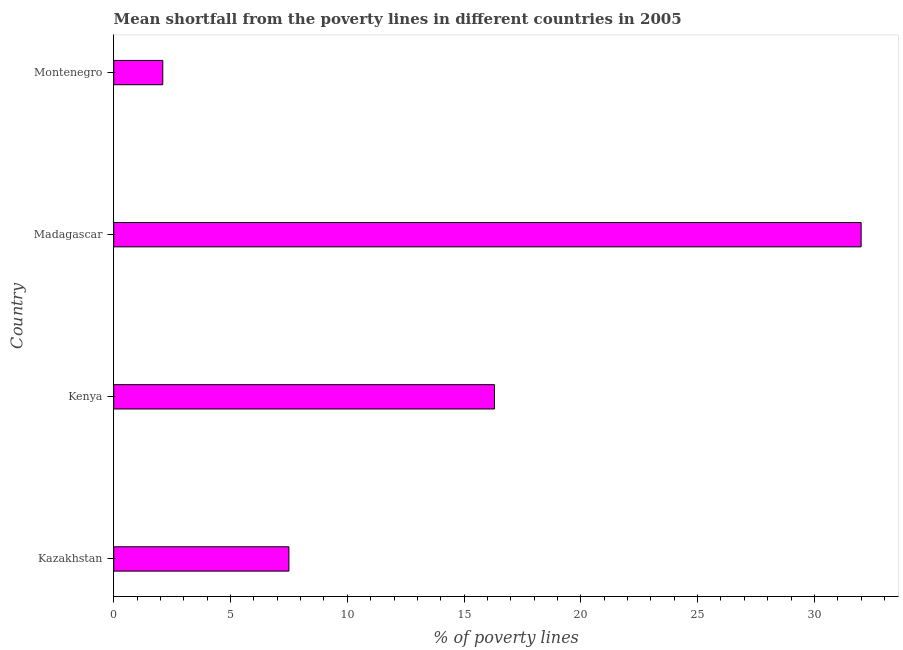Does the graph contain any zero values?
Ensure brevity in your answer.  No. Does the graph contain grids?
Your answer should be very brief. No. What is the title of the graph?
Your response must be concise. Mean shortfall from the poverty lines in different countries in 2005. What is the label or title of the X-axis?
Make the answer very short. % of poverty lines. In which country was the poverty gap at national poverty lines maximum?
Provide a short and direct response. Madagascar. In which country was the poverty gap at national poverty lines minimum?
Offer a very short reply. Montenegro. What is the sum of the poverty gap at national poverty lines?
Keep it short and to the point. 57.9. What is the difference between the poverty gap at national poverty lines in Kazakhstan and Madagascar?
Provide a short and direct response. -24.5. What is the average poverty gap at national poverty lines per country?
Your answer should be very brief. 14.47. In how many countries, is the poverty gap at national poverty lines greater than 7 %?
Your answer should be compact. 3. What is the ratio of the poverty gap at national poverty lines in Kazakhstan to that in Kenya?
Offer a very short reply. 0.46. What is the difference between the highest and the second highest poverty gap at national poverty lines?
Provide a short and direct response. 15.7. What is the difference between the highest and the lowest poverty gap at national poverty lines?
Give a very brief answer. 29.9. In how many countries, is the poverty gap at national poverty lines greater than the average poverty gap at national poverty lines taken over all countries?
Your response must be concise. 2. Are all the bars in the graph horizontal?
Offer a very short reply. Yes. What is the difference between two consecutive major ticks on the X-axis?
Ensure brevity in your answer.  5. What is the % of poverty lines in Kenya?
Offer a terse response. 16.3. What is the % of poverty lines of Madagascar?
Offer a terse response. 32. What is the difference between the % of poverty lines in Kazakhstan and Kenya?
Provide a short and direct response. -8.8. What is the difference between the % of poverty lines in Kazakhstan and Madagascar?
Make the answer very short. -24.5. What is the difference between the % of poverty lines in Kazakhstan and Montenegro?
Give a very brief answer. 5.4. What is the difference between the % of poverty lines in Kenya and Madagascar?
Ensure brevity in your answer.  -15.7. What is the difference between the % of poverty lines in Madagascar and Montenegro?
Your answer should be compact. 29.9. What is the ratio of the % of poverty lines in Kazakhstan to that in Kenya?
Your answer should be compact. 0.46. What is the ratio of the % of poverty lines in Kazakhstan to that in Madagascar?
Provide a succinct answer. 0.23. What is the ratio of the % of poverty lines in Kazakhstan to that in Montenegro?
Provide a short and direct response. 3.57. What is the ratio of the % of poverty lines in Kenya to that in Madagascar?
Your answer should be compact. 0.51. What is the ratio of the % of poverty lines in Kenya to that in Montenegro?
Offer a terse response. 7.76. What is the ratio of the % of poverty lines in Madagascar to that in Montenegro?
Ensure brevity in your answer.  15.24. 